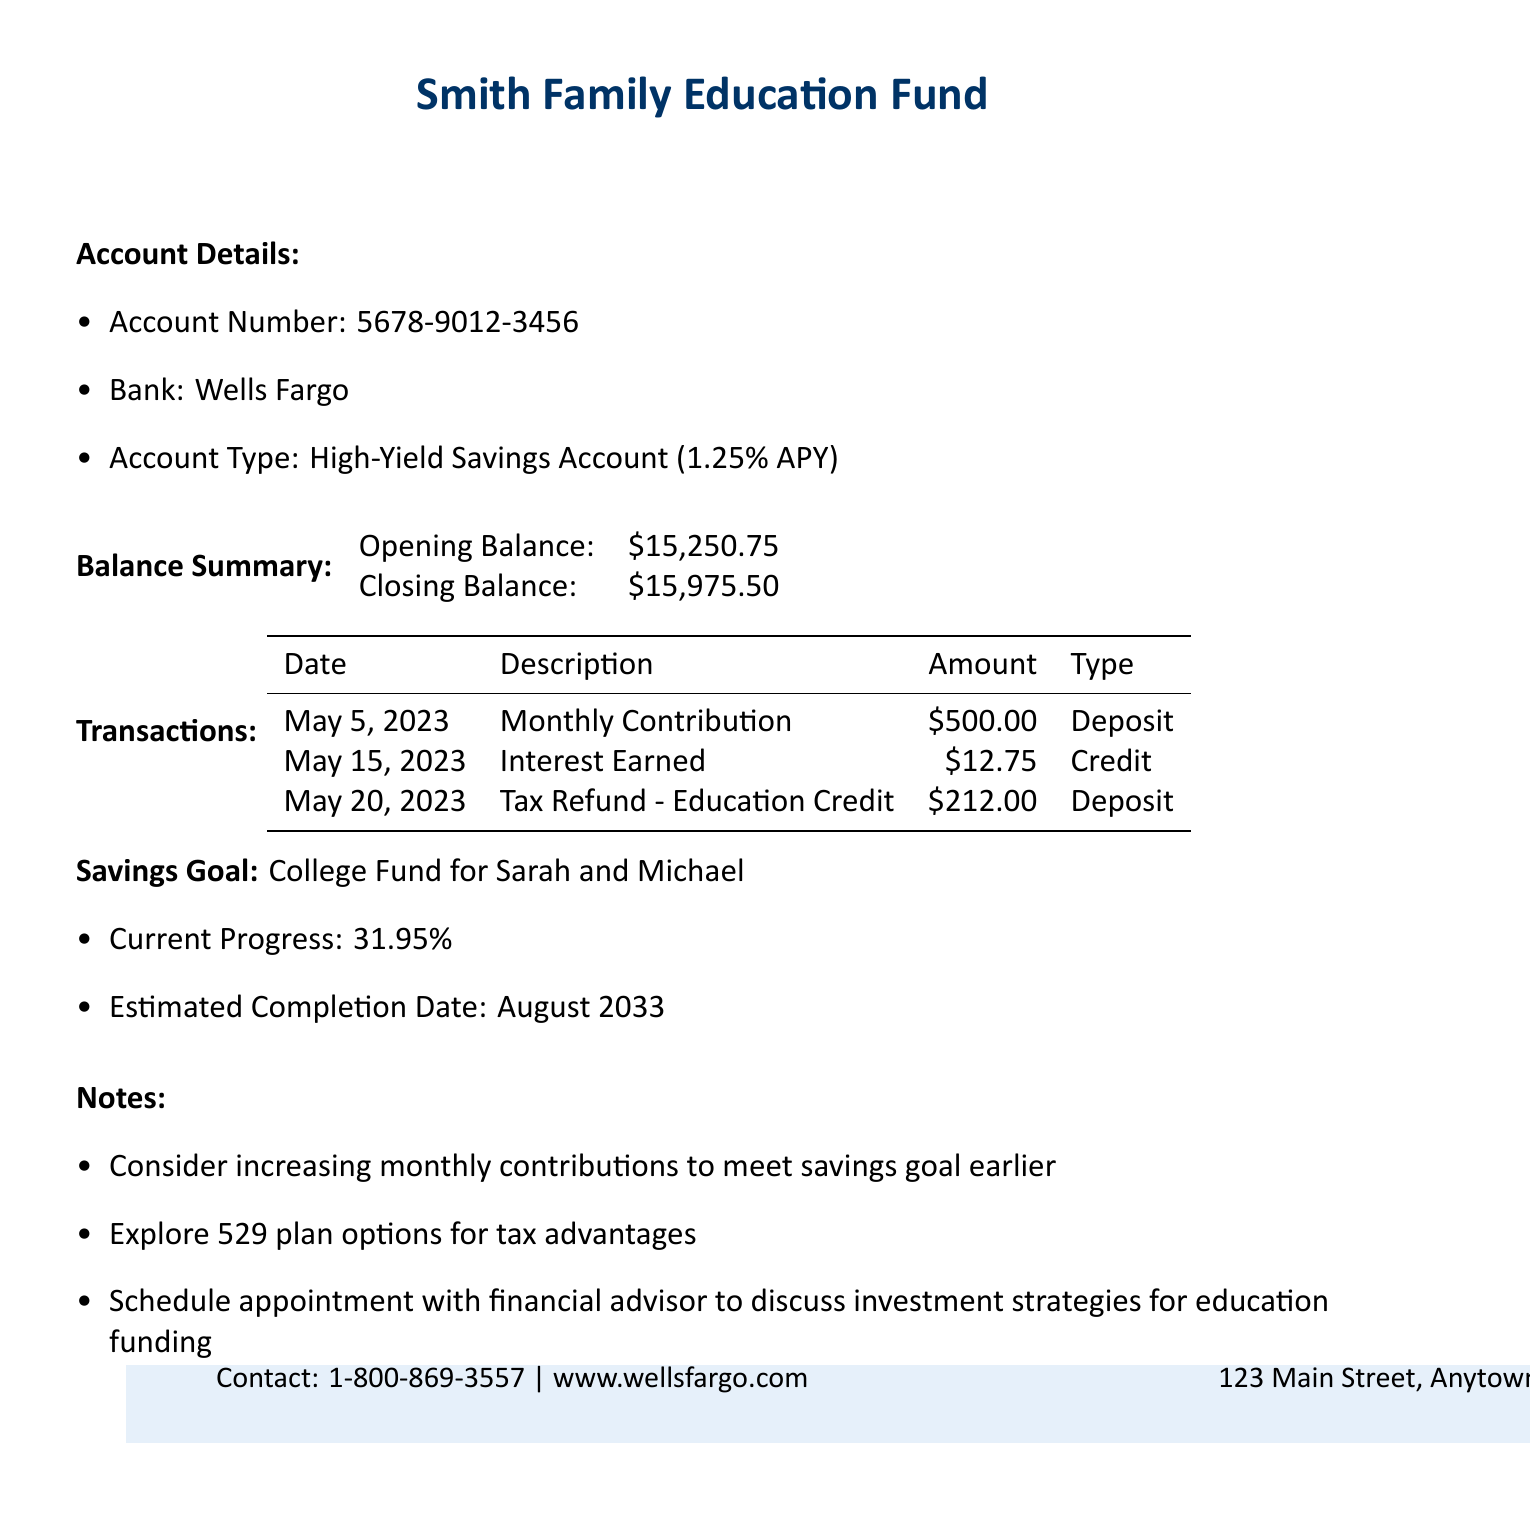What is the account name? The account name is stated clearly in the document.
Answer: Smith Family Education Fund What is the closing balance? The closing balance is shown in the balance summary section.
Answer: $15,975.50 What is the monthly contribution amount? The monthly contribution amount can be found in the transactions list.
Answer: $500.00 What is the current progress towards the savings goal? Current progress towards the savings goal is included in the savings goal section.
Answer: 31.95% What is the estimated completion date for the savings goal? The estimated completion date is mentioned in the savings goal section.
Answer: August 2033 How much interest was earned in May? The amount of interest earned during May is specified in the transactions.
Answer: $12.75 What type of account is this? The account type is explicitly described in the account details section.
Answer: High-Yield Savings Account Which bank holds the account? The bank holding the account is clearly indicated in the document.
Answer: Wells Fargo What advice is provided regarding contributions? Some notes contain advice on contributions that can be found in the notes section.
Answer: Consider increasing monthly contributions to meet savings goal earlier 